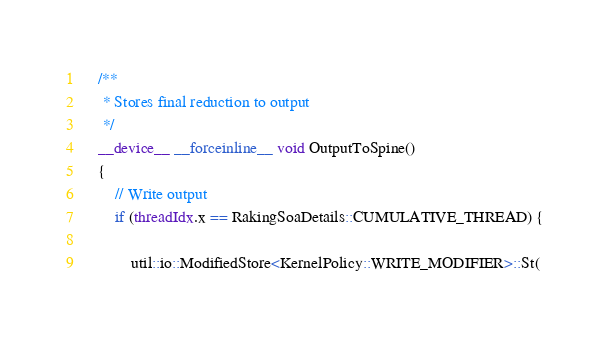<code> <loc_0><loc_0><loc_500><loc_500><_Cuda_>

	/**
	 * Stores final reduction to output
	 */
	__device__ __forceinline__ void OutputToSpine()
	{
		// Write output
		if (threadIdx.x == RakingSoaDetails::CUMULATIVE_THREAD) {

			util::io::ModifiedStore<KernelPolicy::WRITE_MODIFIER>::St(</code> 